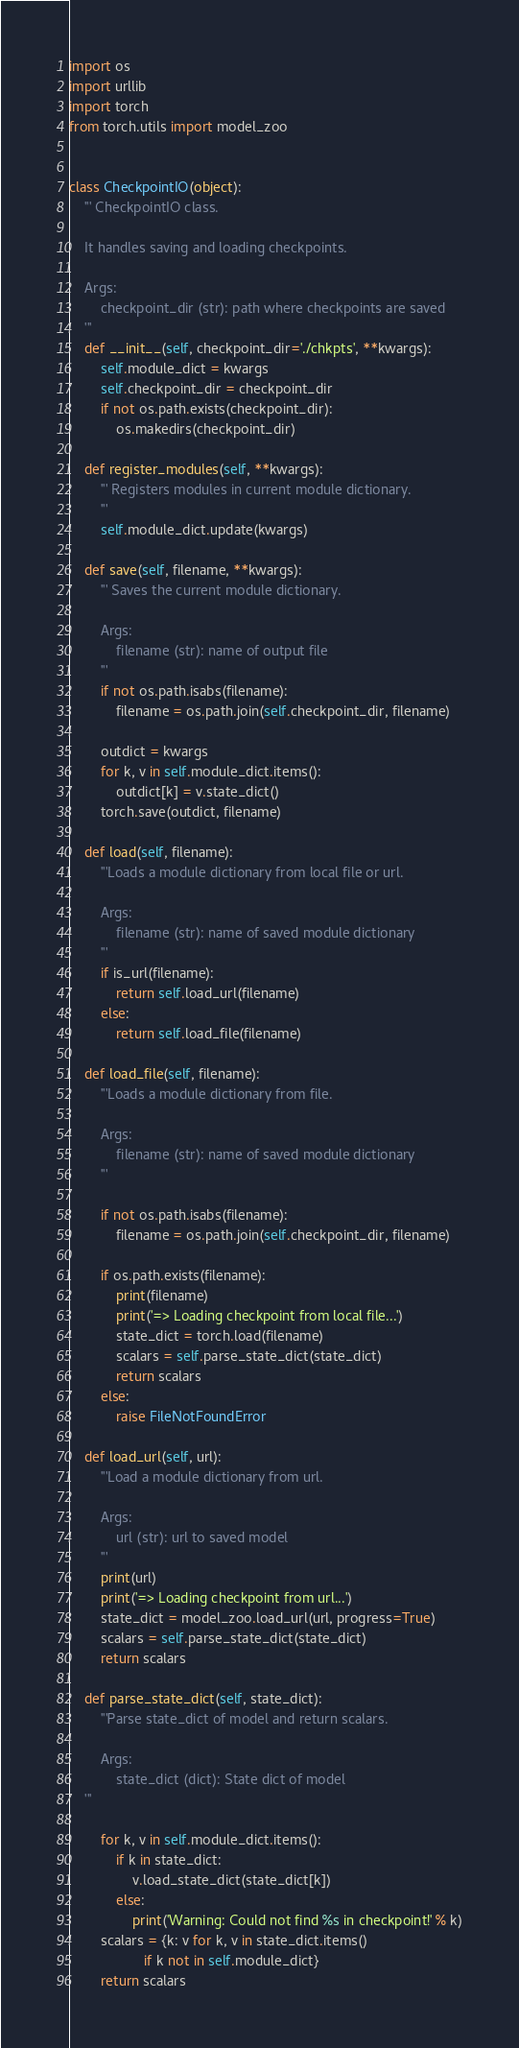<code> <loc_0><loc_0><loc_500><loc_500><_Python_>
import os
import urllib
import torch
from torch.utils import model_zoo


class CheckpointIO(object):
    ''' CheckpointIO class.

    It handles saving and loading checkpoints.

    Args:
        checkpoint_dir (str): path where checkpoints are saved
    '''
    def __init__(self, checkpoint_dir='./chkpts', **kwargs):
        self.module_dict = kwargs
        self.checkpoint_dir = checkpoint_dir
        if not os.path.exists(checkpoint_dir):
            os.makedirs(checkpoint_dir)

    def register_modules(self, **kwargs):
        ''' Registers modules in current module dictionary.
        '''
        self.module_dict.update(kwargs)

    def save(self, filename, **kwargs):
        ''' Saves the current module dictionary.

        Args:
            filename (str): name of output file
        '''
        if not os.path.isabs(filename):
            filename = os.path.join(self.checkpoint_dir, filename)

        outdict = kwargs
        for k, v in self.module_dict.items():
            outdict[k] = v.state_dict()
        torch.save(outdict, filename)

    def load(self, filename):
        '''Loads a module dictionary from local file or url.
        
        Args:
            filename (str): name of saved module dictionary
        '''
        if is_url(filename):
            return self.load_url(filename)
        else:
            return self.load_file(filename)

    def load_file(self, filename):
        '''Loads a module dictionary from file.
        
        Args:
            filename (str): name of saved module dictionary
        '''

        if not os.path.isabs(filename):
            filename = os.path.join(self.checkpoint_dir, filename)

        if os.path.exists(filename):
            print(filename)
            print('=> Loading checkpoint from local file...')
            state_dict = torch.load(filename)
            scalars = self.parse_state_dict(state_dict)
            return scalars
        else:
            raise FileNotFoundError

    def load_url(self, url):
        '''Load a module dictionary from url.
        
        Args:
            url (str): url to saved model
        '''
        print(url)
        print('=> Loading checkpoint from url...')
        state_dict = model_zoo.load_url(url, progress=True)
        scalars = self.parse_state_dict(state_dict)
        return scalars

    def parse_state_dict(self, state_dict):
        '''Parse state_dict of model and return scalars.
        
        Args:
            state_dict (dict): State dict of model
    '''

        for k, v in self.module_dict.items():
            if k in state_dict:
                v.load_state_dict(state_dict[k])
            else:
                print('Warning: Could not find %s in checkpoint!' % k)
        scalars = {k: v for k, v in state_dict.items()
                   if k not in self.module_dict}
        return scalars
</code> 